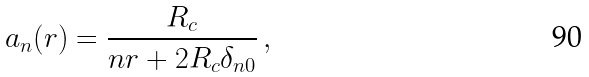<formula> <loc_0><loc_0><loc_500><loc_500>a _ { n } ( r ) = \frac { R _ { c } } { n r + 2 R _ { c } \delta _ { n 0 } } \, ,</formula> 